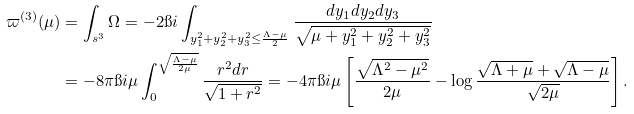<formula> <loc_0><loc_0><loc_500><loc_500>\varpi ^ { ( 3 ) } ( \mu ) & = \int _ { \real s ^ { 3 } } \Omega = - 2 \i i \int _ { y _ { 1 } ^ { 2 } + y _ { 2 } ^ { 2 } + y _ { 3 } ^ { 2 } \leq \frac { \Lambda - \mu } 2 } \frac { d y _ { 1 } d y _ { 2 } d y _ { 3 } } { \sqrt { \mu + y _ { 1 } ^ { 2 } + y _ { 2 } ^ { 2 } + y _ { 3 } ^ { 2 } } } \\ & = - 8 \pi \i i \mu \int _ { 0 } ^ { \sqrt { \frac { \Lambda - \mu } { 2 \mu } } } \frac { r ^ { 2 } d r } { \sqrt { 1 + r ^ { 2 } } } = - 4 \pi \i i \mu \left [ \frac { \sqrt { \Lambda ^ { 2 } - \mu ^ { 2 } } } { 2 \mu } - \log \frac { \sqrt { \Lambda + \mu } + \sqrt { \Lambda - \mu } } { \sqrt { 2 \mu } } \right ] .</formula> 